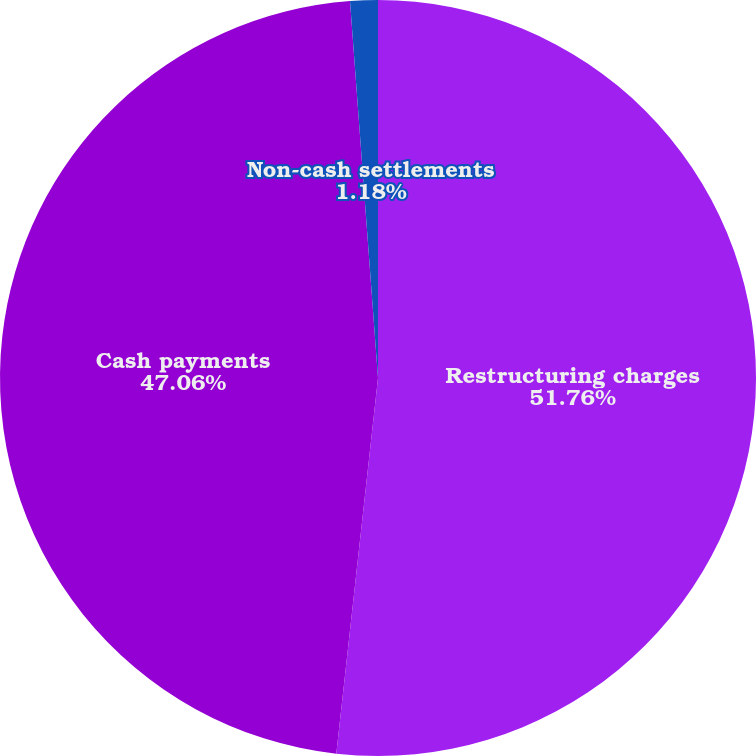Convert chart. <chart><loc_0><loc_0><loc_500><loc_500><pie_chart><fcel>Restructuring charges<fcel>Cash payments<fcel>Non-cash settlements<nl><fcel>51.76%<fcel>47.06%<fcel>1.18%<nl></chart> 